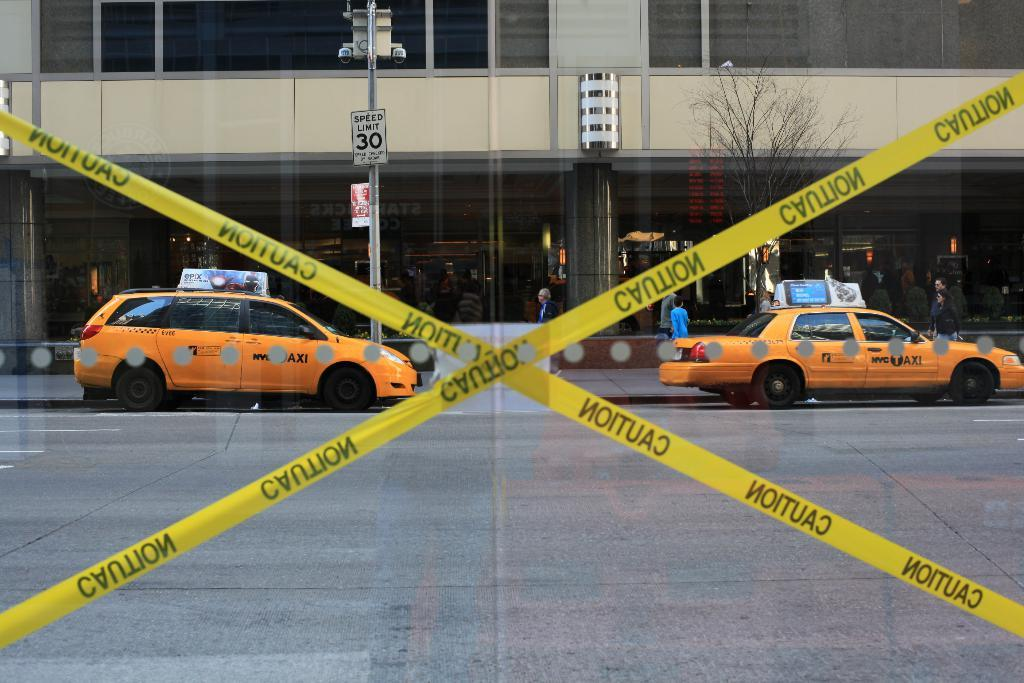<image>
Give a short and clear explanation of the subsequent image. Two taxis driving in front of a yellow tape that says caution on it. 